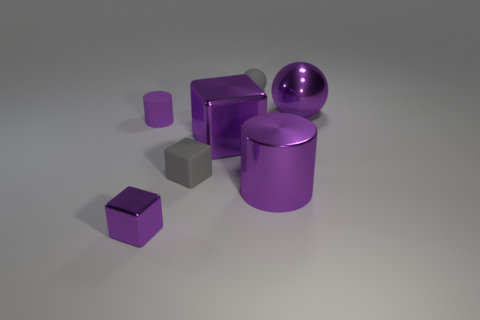Add 3 metallic cubes. How many objects exist? 10 Subtract all balls. How many objects are left? 5 Add 5 tiny gray things. How many tiny gray things exist? 7 Subtract 0 yellow cubes. How many objects are left? 7 Subtract all purple metallic things. Subtract all purple metal spheres. How many objects are left? 2 Add 3 gray things. How many gray things are left? 5 